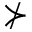<formula> <loc_0><loc_0><loc_500><loc_500>\nsucc</formula> 